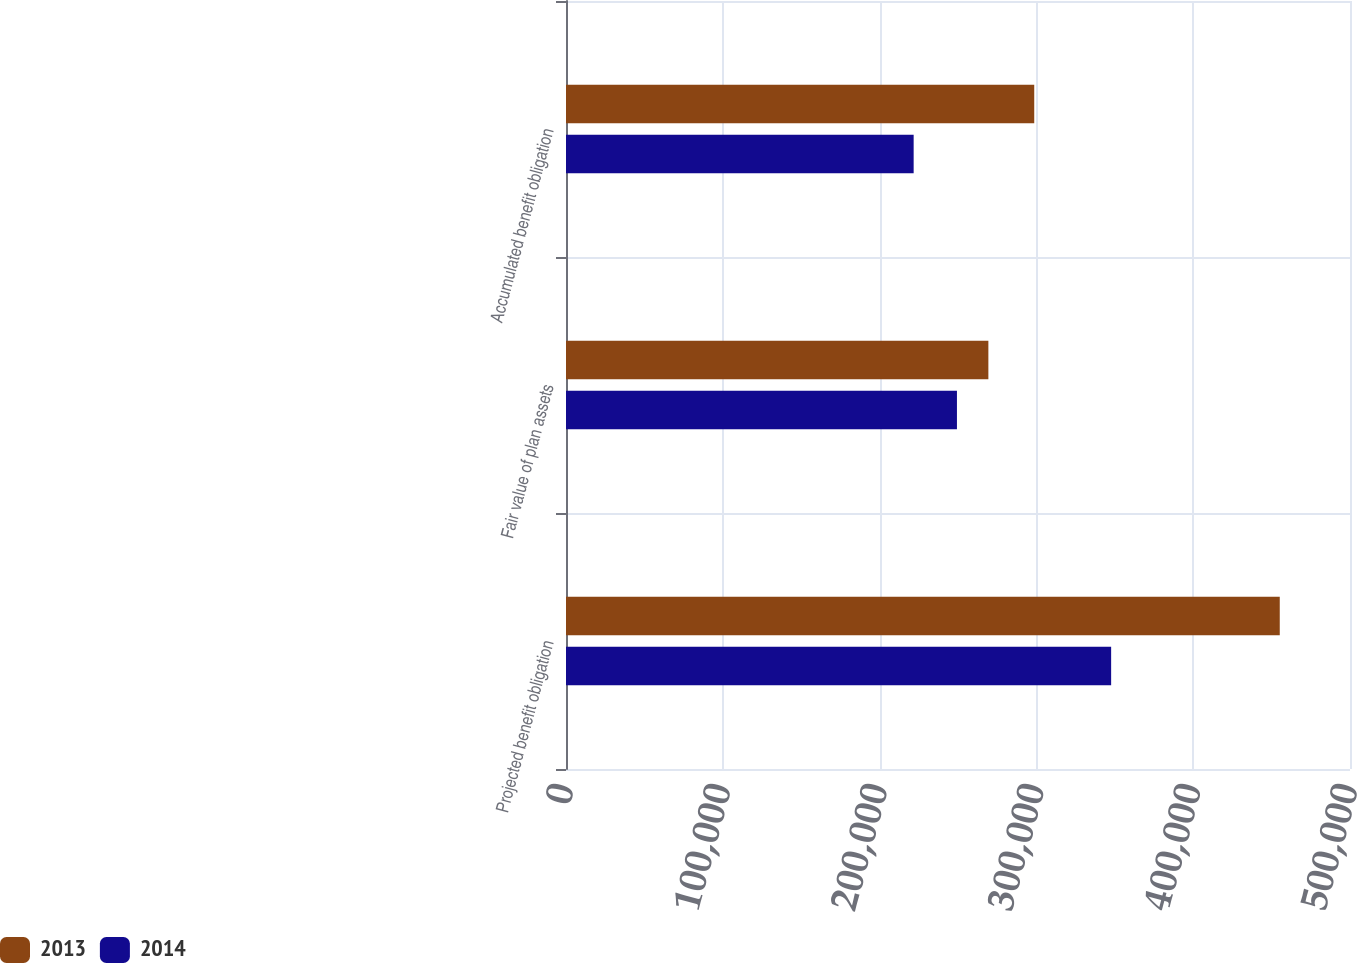Convert chart. <chart><loc_0><loc_0><loc_500><loc_500><stacked_bar_chart><ecel><fcel>Projected benefit obligation<fcel>Fair value of plan assets<fcel>Accumulated benefit obligation<nl><fcel>2013<fcel>455205<fcel>269371<fcel>298620<nl><fcel>2014<fcel>347665<fcel>249329<fcel>221715<nl></chart> 